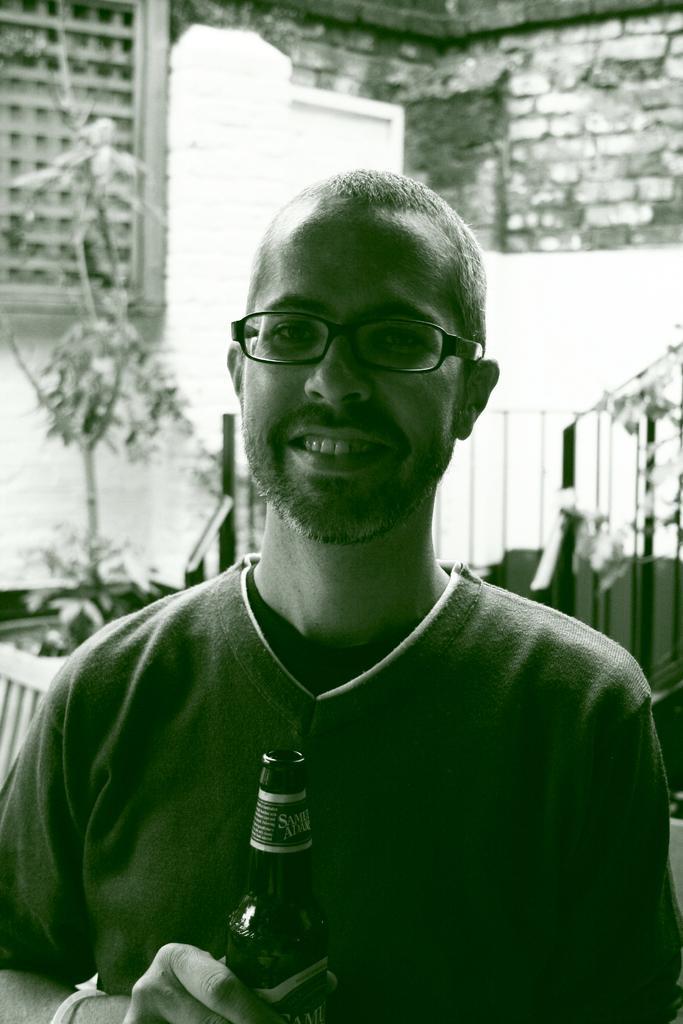Could you give a brief overview of what you see in this image? In this picture we can see a man wearing spectacles and he is holding a bottle in his hand. On the background we can see wall with bricks. Here we can see a plant. 